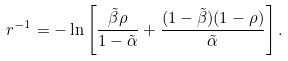<formula> <loc_0><loc_0><loc_500><loc_500>r ^ { - 1 } = - \ln \left [ \frac { \tilde { \beta } \rho } { 1 - \tilde { \alpha } } + \frac { ( 1 - \tilde { \beta } ) ( 1 - \rho ) } { \tilde { \alpha } } \right ] .</formula> 